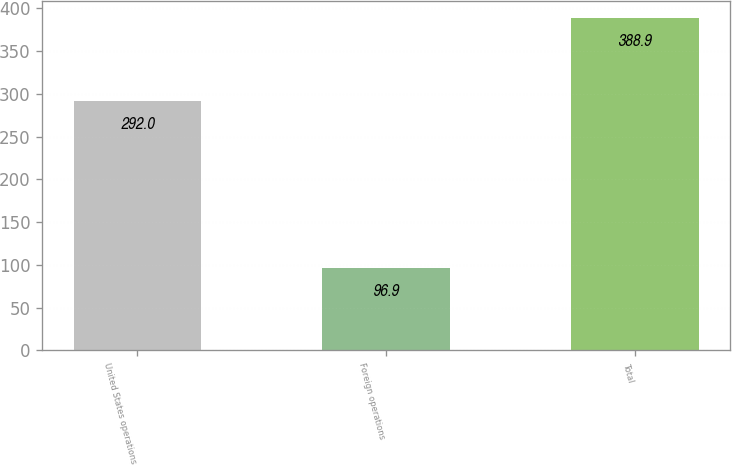Convert chart. <chart><loc_0><loc_0><loc_500><loc_500><bar_chart><fcel>United States operations<fcel>Foreign operations<fcel>Total<nl><fcel>292<fcel>96.9<fcel>388.9<nl></chart> 